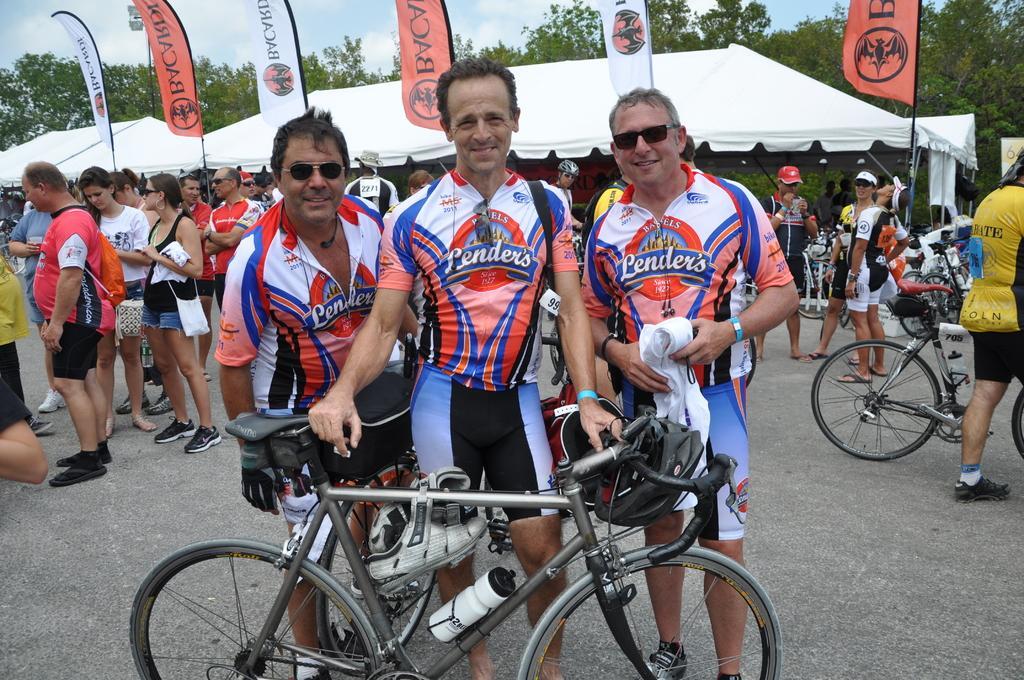Can you describe this image briefly? In this image we can see a cycle with bottle, shoes and helmet. Near to the cycle there are three persons standing. Two persons are wearing goggles. In the back we can see many people. Some are wearing caps. Some are holding bags. Also there are cycles. In the background there are tents. And we can see banners. In the background there are trees and sky with clouds. 